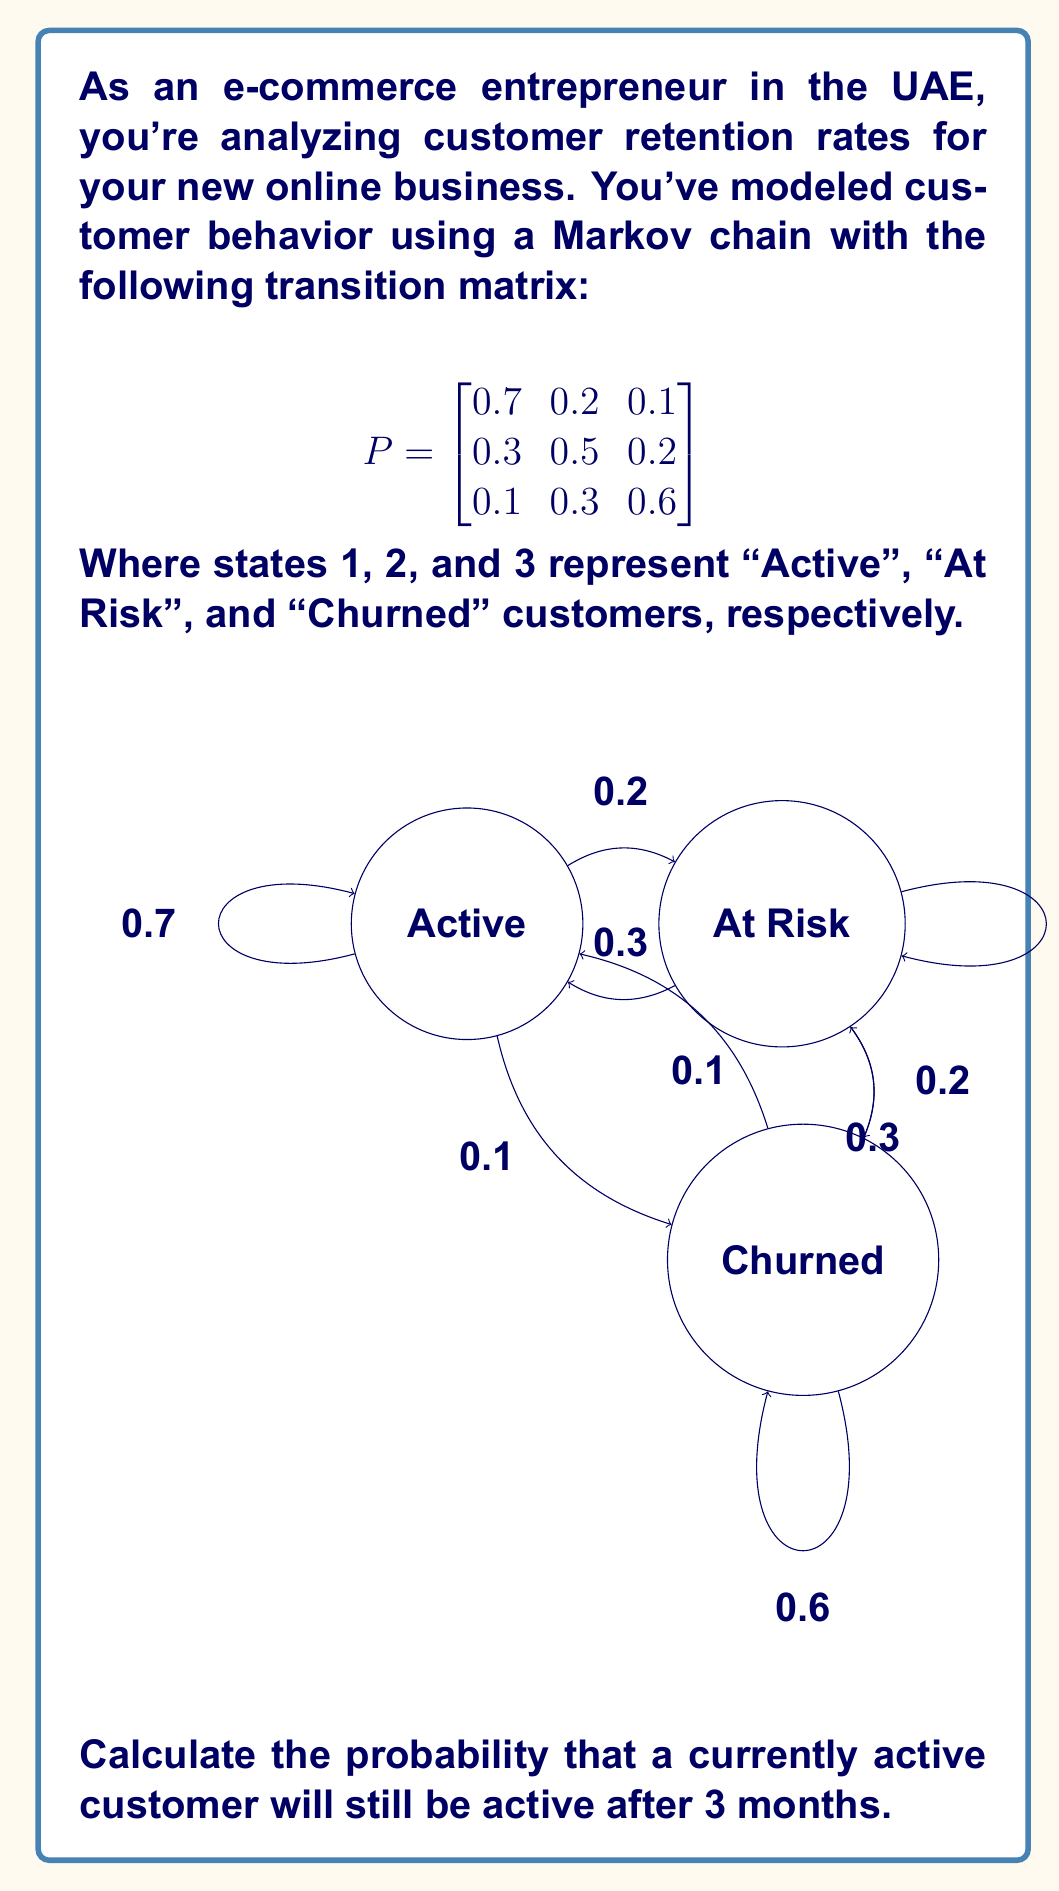Help me with this question. To solve this problem, we need to use the properties of Markov chains and matrix multiplication. Here's a step-by-step approach:

1) The transition matrix $P$ represents the probabilities of moving between states in one step (or one month in this case).

2) To find the probabilities after 3 months, we need to calculate $P^3$.

3) We can do this by multiplying $P$ by itself three times:

   $P^3 = P \times P \times P$

4) Let's perform the matrix multiplication:

   $P^2 = \begin{bmatrix}
   0.7 & 0.2 & 0.1 \\
   0.3 & 0.5 & 0.2 \\
   0.1 & 0.3 & 0.6
   \end{bmatrix} \times \begin{bmatrix}
   0.7 & 0.2 & 0.1 \\
   0.3 & 0.5 & 0.2 \\
   0.1 & 0.3 & 0.6
   \end{bmatrix} = \begin{bmatrix}
   0.56 & 0.29 & 0.15 \\
   0.40 & 0.41 & 0.19 \\
   0.22 & 0.36 & 0.42
   \end{bmatrix}$

   $P^3 = P^2 \times P = \begin{bmatrix}
   0.56 & 0.29 & 0.15 \\
   0.40 & 0.41 & 0.19 \\
   0.22 & 0.36 & 0.42
   \end{bmatrix} \times \begin{bmatrix}
   0.7 & 0.2 & 0.1 \\
   0.3 & 0.5 & 0.2 \\
   0.1 & 0.3 & 0.6
   \end{bmatrix} = \begin{bmatrix}
   0.497 & 0.331 & 0.172 \\
   0.425 & 0.385 & 0.190 \\
   0.289 & 0.371 & 0.340
   \end{bmatrix}$

5) The probability we're looking for is in the first row, first column of $P^3$, as this represents the probability of starting in the "Active" state and ending in the "Active" state after 3 steps.

Therefore, the probability that a currently active customer will still be active after 3 months is 0.497 or approximately 49.7%.
Answer: 0.497 